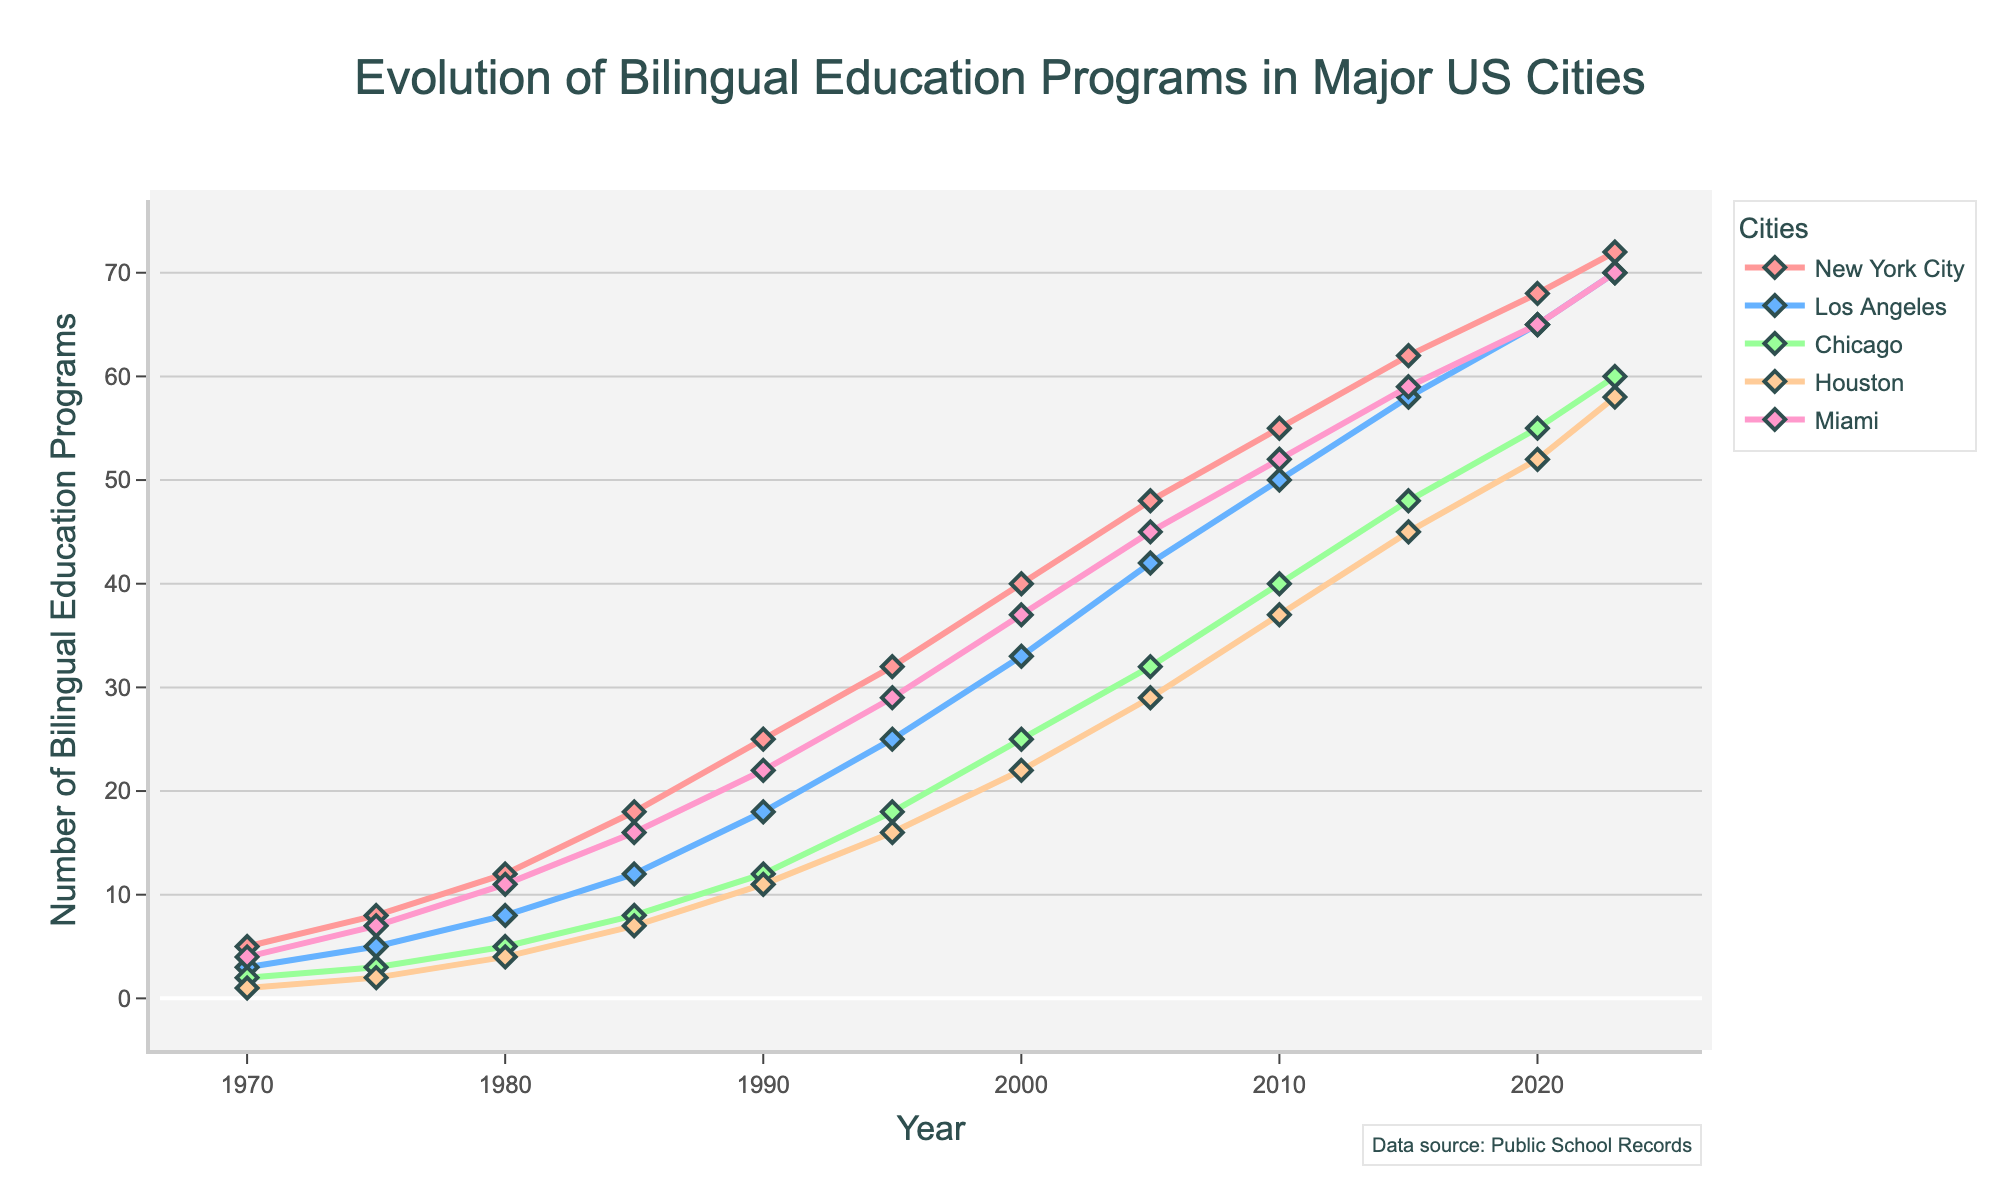what city had the most significant increase in bilingual education programs from 1970 to 2023? To determine the city with the most significant increase in bilingual education programs from 1970 to 2023, we look at the difference in numbers for each city between these years. New York City increased from 5 to 72 (67 programs), Los Angeles from 3 to 70 (67 programs), Chicago from 2 to 60 (58 programs), Houston from 1 to 58 (57 programs), and Miami from 4 to 70 (66 programs). The most significant increase is a tie between New York City and Los Angeles.
Answer: New York City and Los Angeles By how many programs did the number of bilingual education programs in Houston increase between 1980 and 2010? To find the increase in bilingual education programs in Houston between 1980 and 2010, we subtract the number for 1980 from the number for 2010. In 1980, Houston had 4 programs, and in 2010, it had 37 programs. The increase is 37 - 4 = 33 programs.
Answer: 33 Which city had the smallest number of bilingual education programs in 1985, and how many programs did it have? To find the city with the smallest number of bilingual education programs in 1985, we compare the numbers for that year across all cities. New York City had 18, Los Angeles 12, Chicago 8, Houston 7, and Miami 16. The smallest number was in Houston, with 7 programs.
Answer: Houston, 7 What is the average number of bilingual education programs in Miami across all of the years presented? To find the average number of programs in Miami, we sum the numbers for all the years and divide by the number of years. Sum = 4 + 7 + 11 + 16 + 22 + 29 + 37 + 45 + 52 + 59 + 65 + 70 = 417. There are 12 data points, so the average is 417/12 ≈ 34.75.
Answer: 34.75 By what percentage did the number of bilingual education programs in Chicago increase from 1970 to 2023? To find the percentage increase, we first determine the increase in number, which is 60 (2023) - 2 (1970) = 58. Then we divide this increase by the original number and multiply by 100. (58 / 2) * 100 = 2900%.
Answer: 2900% Which city had the closest number of bilingual education programs to the average number of programs in 2000 across all cities? First, we calculate the average number of programs in 2000 across all cities. Sum = 40 + 33 + 25 + 22 + 37 = 157. Average = 157 / 5 = 31.4. The numbers for each city in 2000 are New York City 40, Los Angeles 33, Chicago 25, Houston 22, and Miami 37. The closest number to 31.4 is 33 (Los Angeles).
Answer: Los Angeles Which city showed the most consistent growth in bilingual education programs over the years? To determine consistent growth, we look at the trends for each city. New York City, Los Angeles, Chicago, Houston, and Miami all show an upward trend, but New York City and Los Angeles show a steady, linear-like increase without major deviations. A closer look could be done to focus on year-by-year increments, but visually, New York City seems the most consistent.
Answer: New York City 